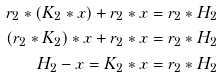Convert formula to latex. <formula><loc_0><loc_0><loc_500><loc_500>r _ { 2 } * ( K _ { 2 } * x ) + r _ { 2 } * x & = r _ { 2 } * H _ { 2 } \\ ( r _ { 2 } * K _ { 2 } ) * x + r _ { 2 } * x & = r _ { 2 } * H _ { 2 } \\ H _ { 2 } - x = K _ { 2 } * x & = r _ { 2 } * H _ { 2 }</formula> 